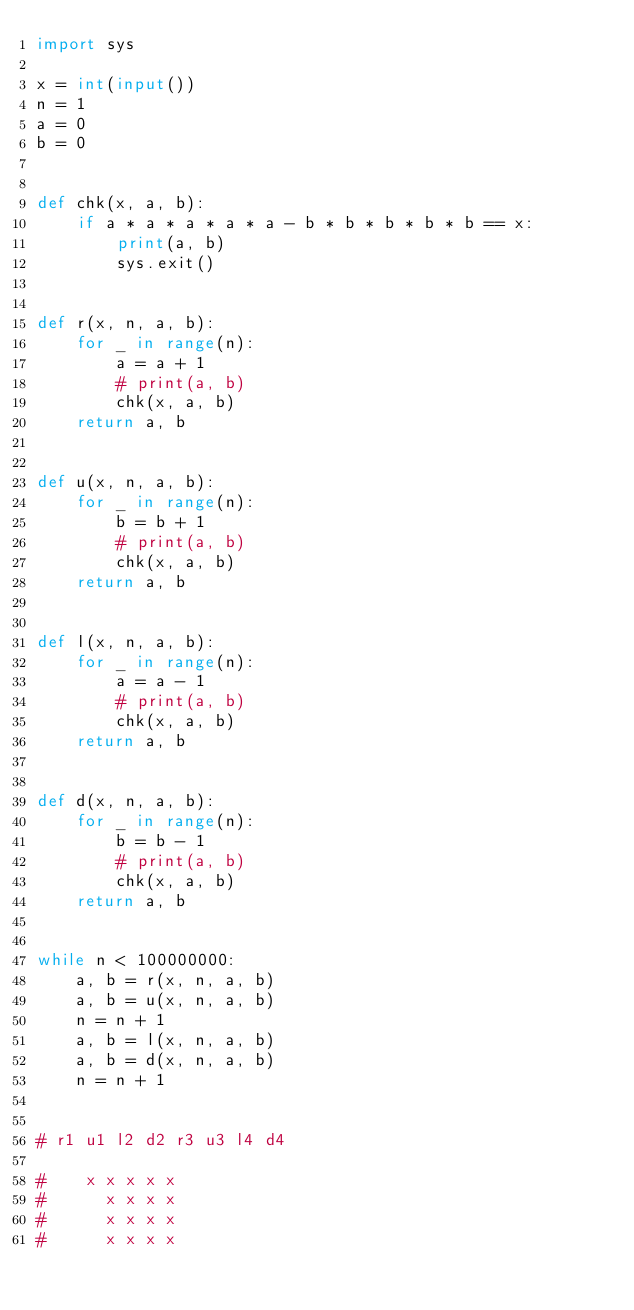<code> <loc_0><loc_0><loc_500><loc_500><_Python_>import sys

x = int(input())
n = 1
a = 0
b = 0


def chk(x, a, b):
    if a * a * a * a * a - b * b * b * b * b == x:
        print(a, b)
        sys.exit()


def r(x, n, a, b):
    for _ in range(n):
        a = a + 1
        # print(a, b)
        chk(x, a, b)
    return a, b


def u(x, n, a, b):
    for _ in range(n):
        b = b + 1
        # print(a, b)
        chk(x, a, b)
    return a, b


def l(x, n, a, b):
    for _ in range(n):
        a = a - 1
        # print(a, b)
        chk(x, a, b)
    return a, b


def d(x, n, a, b):
    for _ in range(n):
        b = b - 1
        # print(a, b)
        chk(x, a, b)
    return a, b


while n < 100000000:
    a, b = r(x, n, a, b)
    a, b = u(x, n, a, b)
    n = n + 1
    a, b = l(x, n, a, b)
    a, b = d(x, n, a, b)
    n = n + 1


# r1 u1 l2 d2 r3 u3 l4 d4

#    x x x x x
#      x x x x
#      x x x x
#      x x x x
</code> 